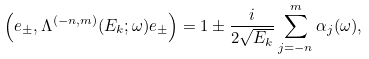Convert formula to latex. <formula><loc_0><loc_0><loc_500><loc_500>\left ( e _ { \pm } , \Lambda ^ { ( - n , m ) } ( E _ { k } ; \omega ) e _ { \pm } \right ) = 1 \pm \frac { i } { 2 \sqrt { E _ { k } } } \sum _ { j = - n } ^ { m } \alpha _ { j } ( \omega ) ,</formula> 